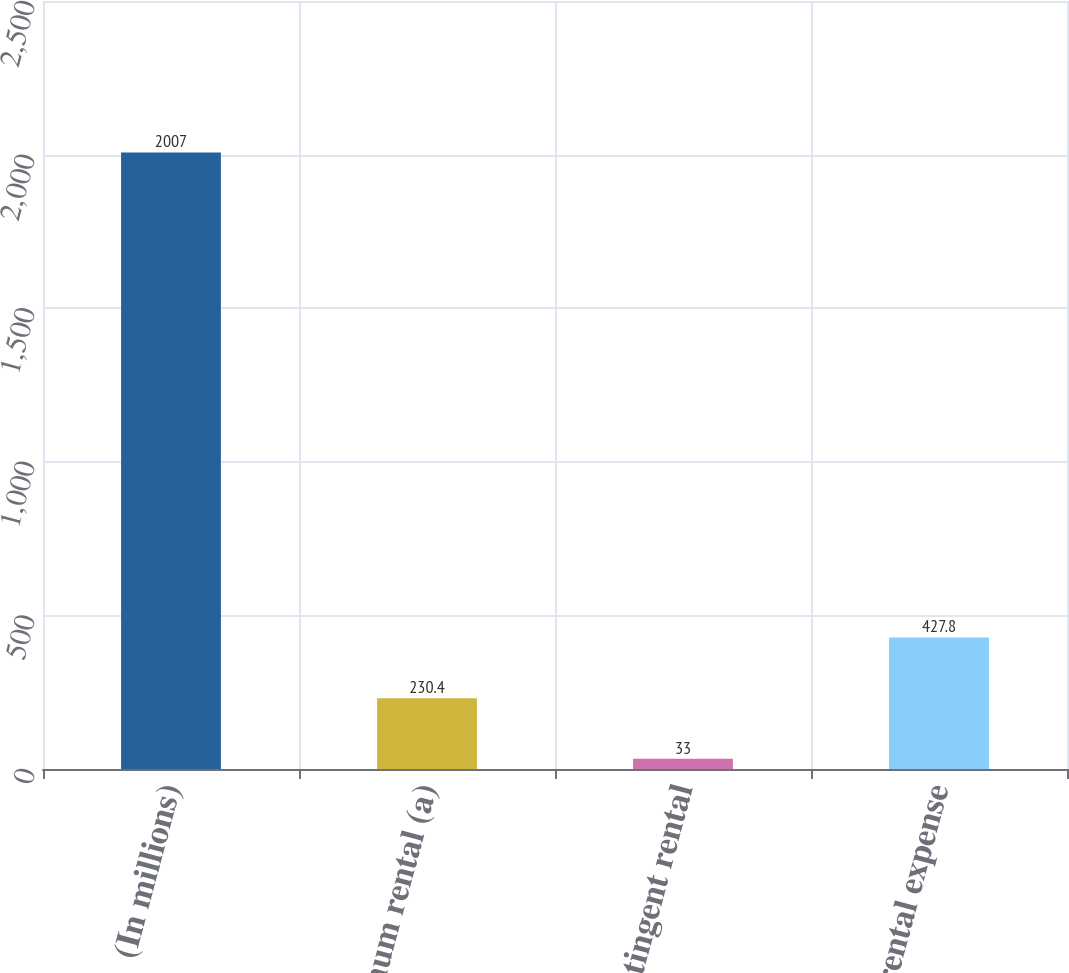<chart> <loc_0><loc_0><loc_500><loc_500><bar_chart><fcel>(In millions)<fcel>Minimum rental (a)<fcel>Contingent rental<fcel>Net rental expense<nl><fcel>2007<fcel>230.4<fcel>33<fcel>427.8<nl></chart> 